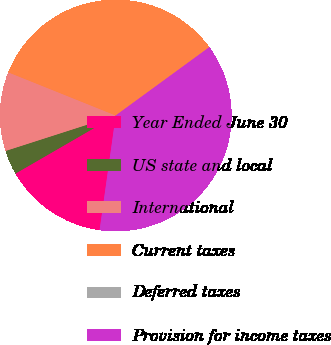<chart> <loc_0><loc_0><loc_500><loc_500><pie_chart><fcel>Year Ended June 30<fcel>US state and local<fcel>International<fcel>Current taxes<fcel>Deferred taxes<fcel>Provision for income taxes<nl><fcel>14.42%<fcel>3.4%<fcel>11.03%<fcel>33.87%<fcel>0.01%<fcel>37.26%<nl></chart> 